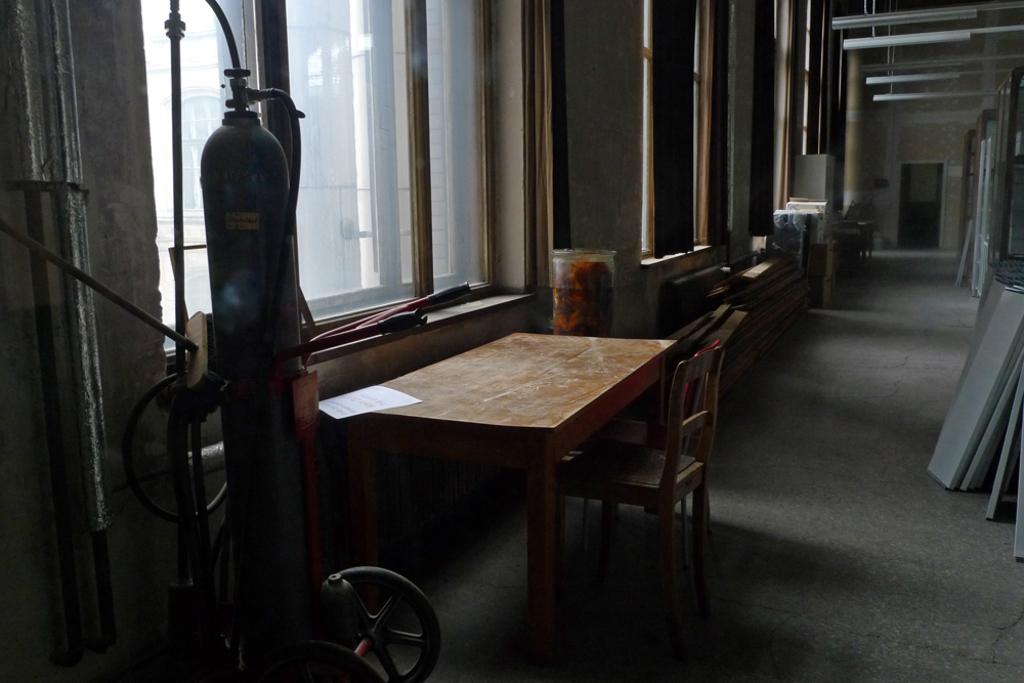What type of furniture is present in the image? There is a chair and a table in the image. Where are the chair and table located in relation to the window? The chair and table are located beside a window. What other object can be seen in the image? There is a gas cylinder on wheels in the image. Where is the gas cylinder located in relation to the table? The gas cylinder is beside the table. How would you describe the size of the hall in the image? The hall is very big. What feature is present on one side of the hall? There are windows on one side of the hall. What type of plants can be seen growing on the key in the image? There are no plants or keys present in the image. 